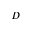Convert formula to latex. <formula><loc_0><loc_0><loc_500><loc_500>D</formula> 